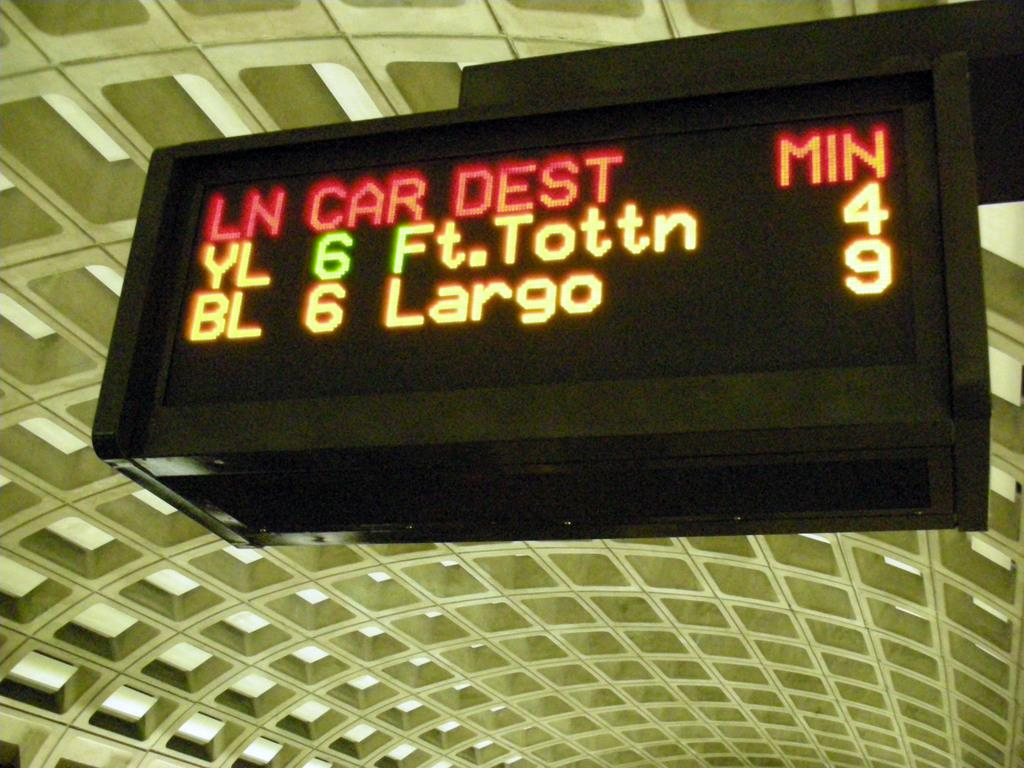<image>
Give a short and clear explanation of the subsequent image. Car 6 in Lane BL going to Largo will arrive in 9 minutes. 